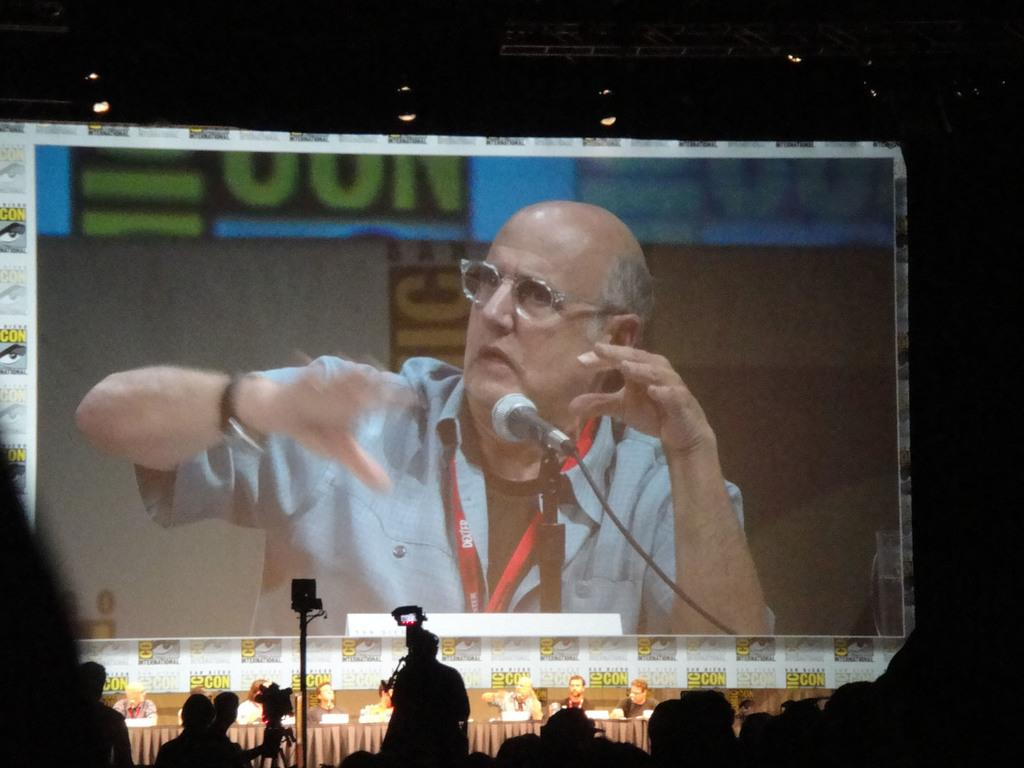What is the main object in the center of the image? There is a projector and a screen in the center of the image. What might the projector and screen be used for? The projector and screen could be used for presentations or movie screenings. Who are the people in the image? There is a group of persons at the bottom of the image. What type of lighting is present at the top of the image? There are LED lights at the top of the image. How many balls are being juggled by the person in the image? There is no person juggling balls in the image; the focus is on the projector, screen, group of persons, and LED lights. 